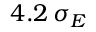<formula> <loc_0><loc_0><loc_500><loc_500>4 . 2 \, \sigma _ { E }</formula> 